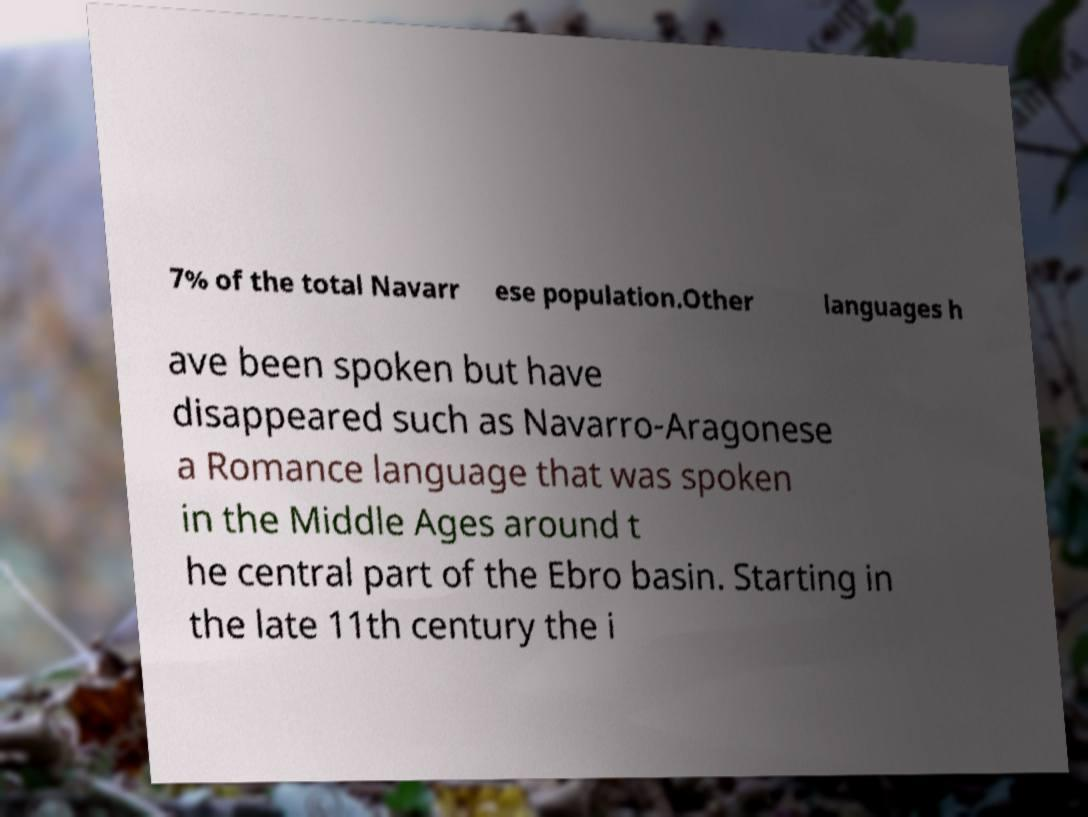There's text embedded in this image that I need extracted. Can you transcribe it verbatim? 7% of the total Navarr ese population.Other languages h ave been spoken but have disappeared such as Navarro-Aragonese a Romance language that was spoken in the Middle Ages around t he central part of the Ebro basin. Starting in the late 11th century the i 